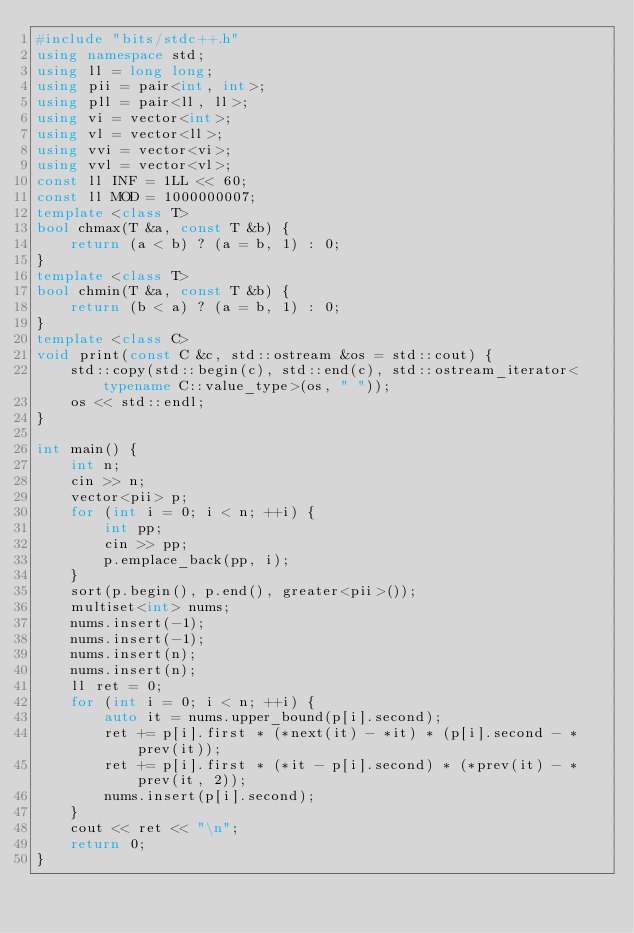Convert code to text. <code><loc_0><loc_0><loc_500><loc_500><_C++_>#include "bits/stdc++.h"
using namespace std;
using ll = long long;
using pii = pair<int, int>;
using pll = pair<ll, ll>;
using vi = vector<int>;
using vl = vector<ll>;
using vvi = vector<vi>;
using vvl = vector<vl>;
const ll INF = 1LL << 60;
const ll MOD = 1000000007;
template <class T>
bool chmax(T &a, const T &b) {
    return (a < b) ? (a = b, 1) : 0;
}
template <class T>
bool chmin(T &a, const T &b) {
    return (b < a) ? (a = b, 1) : 0;
}
template <class C>
void print(const C &c, std::ostream &os = std::cout) {
    std::copy(std::begin(c), std::end(c), std::ostream_iterator<typename C::value_type>(os, " "));
    os << std::endl;
}

int main() {
    int n;
    cin >> n;
    vector<pii> p;
    for (int i = 0; i < n; ++i) {
        int pp;
        cin >> pp;
        p.emplace_back(pp, i);
    }
    sort(p.begin(), p.end(), greater<pii>());
    multiset<int> nums;
    nums.insert(-1);
    nums.insert(-1);
    nums.insert(n);
    nums.insert(n);
    ll ret = 0;
    for (int i = 0; i < n; ++i) {
        auto it = nums.upper_bound(p[i].second);
        ret += p[i].first * (*next(it) - *it) * (p[i].second - *prev(it));
        ret += p[i].first * (*it - p[i].second) * (*prev(it) - *prev(it, 2));
        nums.insert(p[i].second);
    }
    cout << ret << "\n";
    return 0;
}</code> 